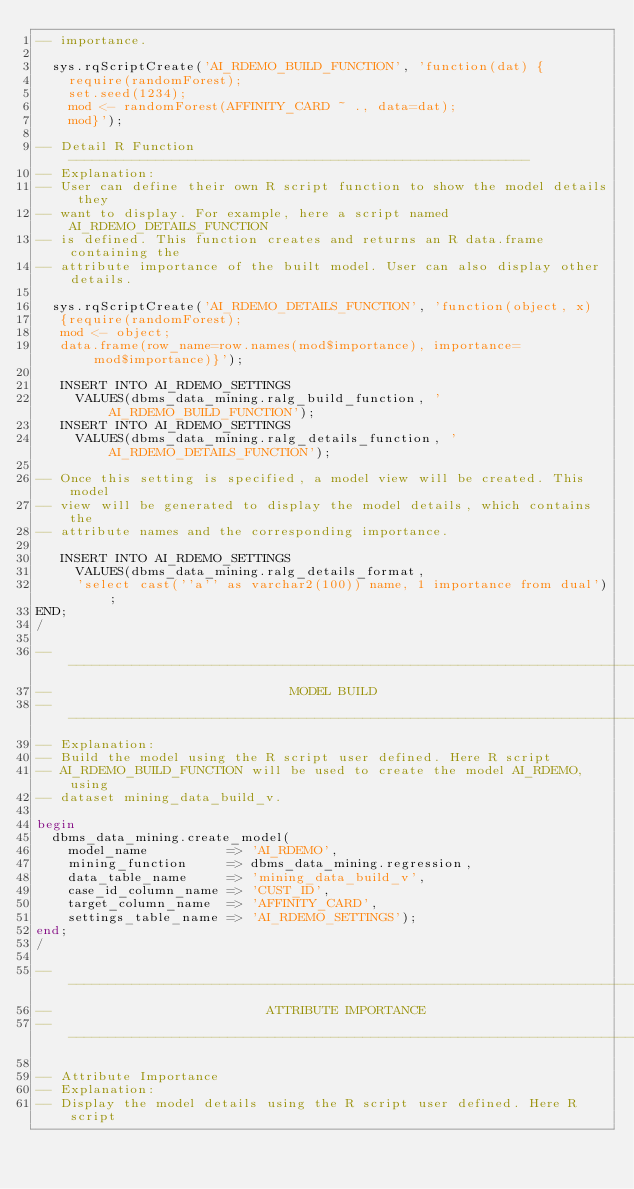<code> <loc_0><loc_0><loc_500><loc_500><_SQL_>-- importance.

  sys.rqScriptCreate('AI_RDEMO_BUILD_FUNCTION', 'function(dat) {
    require(randomForest); 
    set.seed(1234);
    mod <- randomForest(AFFINITY_CARD ~ ., data=dat);
    mod}');

-- Detail R Function ----------------------------------------------------------
-- Explanation:
-- User can define their own R script function to show the model details they
-- want to display. For example, here a script named AI_RDEMO_DETAILS_FUNCTION 
-- is defined. This function creates and returns an R data.frame containing the 
-- attribute importance of the built model. User can also display other details.

  sys.rqScriptCreate('AI_RDEMO_DETAILS_FUNCTION', 'function(object, x)
   {require(randomForest); 
   mod <- object;
   data.frame(row_name=row.names(mod$importance), importance=mod$importance)}');

   INSERT INTO AI_RDEMO_SETTINGS 
     VALUES(dbms_data_mining.ralg_build_function, 'AI_RDEMO_BUILD_FUNCTION');
   INSERT INTO AI_RDEMO_SETTINGS 
     VALUES(dbms_data_mining.ralg_details_function, 'AI_RDEMO_DETAILS_FUNCTION');

-- Once this setting is specified, a model view will be created. This model
-- view will be generated to display the model details, which contains the 
-- attribute names and the corresponding importance.

   INSERT INTO AI_RDEMO_SETTINGS 
     VALUES(dbms_data_mining.ralg_details_format, 
     'select cast(''a'' as varchar2(100)) name, 1 importance from dual');
END;
/

-------------------------------------------------------------------------------
--                              MODEL BUILD
-------------------------------------------------------------------------------
-- Explanation:
-- Build the model using the R script user defined. Here R script 
-- AI_RDEMO_BUILD_FUNCTION will be used to create the model AI_RDEMO, using 
-- dataset mining_data_build_v.

begin
  dbms_data_mining.create_model(
    model_name          => 'AI_RDEMO',
    mining_function     => dbms_data_mining.regression,
    data_table_name     => 'mining_data_build_v',
    case_id_column_name => 'CUST_ID',
    target_column_name  => 'AFFINITY_CARD',
    settings_table_name => 'AI_RDEMO_SETTINGS');
end;
/

-------------------------------------------------------------------------------
--                           ATTRIBUTE IMPORTANCE
-------------------------------------------------------------------------------

-- Attribute Importance
-- Explanation:
-- Display the model details using the R script user defined. Here R script </code> 